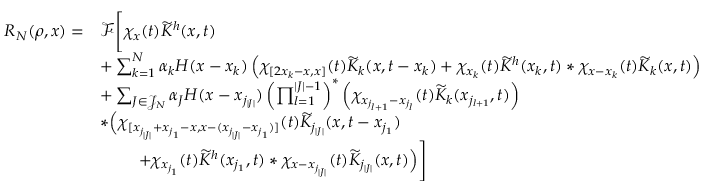Convert formula to latex. <formula><loc_0><loc_0><loc_500><loc_500>\begin{array} { r l } { R _ { N } ( \rho , x ) = } & { \mathcal { F } \left [ \chi _ { x } ( t ) \widetilde { K } ^ { h } ( x , t ) } \\ & { + \sum _ { k = 1 } ^ { N } \alpha _ { k } H ( x - x _ { k } ) \left ( \chi _ { [ 2 x _ { k } - x , x ] } ( t ) \widetilde { K } _ { k } ( x , t - x _ { k } ) + \chi _ { x _ { k } } ( t ) \widetilde { K } ^ { h } ( x _ { k } , t ) \ast \chi _ { x - x _ { k } } ( t ) \widetilde { K } _ { k } ( x , t ) \right ) } \\ & { + \sum _ { J \in \mathcal { J } _ { N } } \alpha _ { J } H ( x - x _ { j _ { | J | } } ) \left ( \prod _ { l = 1 } ^ { | J | - 1 } \right ) ^ { \ast } \left ( \chi _ { x _ { j _ { l + 1 } } - x _ { j _ { l } } } ( t ) \widetilde { K } _ { k } ( x _ { j _ { l + 1 } } , t ) \right ) } \\ & { \ast \left ( \chi _ { [ x _ { j _ { | J | } } + x _ { j _ { 1 } } - x , x - ( x _ { j _ { | J | } } - x _ { j _ { 1 } } ) ] } ( t ) \widetilde { K } _ { j _ { | J | } } ( x , t - x _ { j _ { 1 } } ) } \\ & { \quad \, + \chi _ { x _ { j _ { 1 } } } ( t ) \widetilde { K } ^ { h } ( x _ { j _ { 1 } } , t ) \ast \chi _ { x - x _ { j _ { | J | } } } ( t ) \widetilde { K } _ { j _ { | J | } } ( x , t ) \right ) \right ] } \end{array}</formula> 